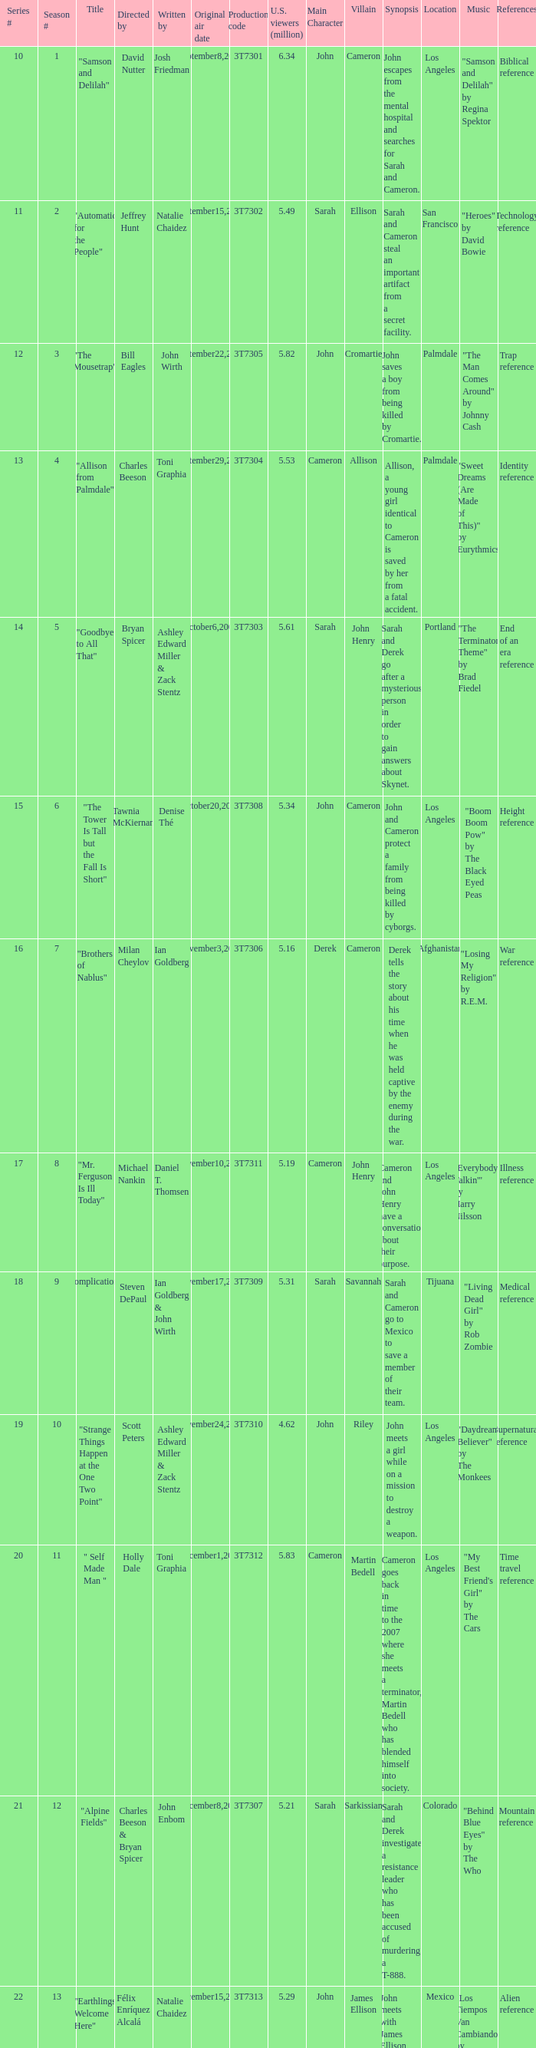Which episode number drew in 3.35 million viewers in the United States? 1.0. 